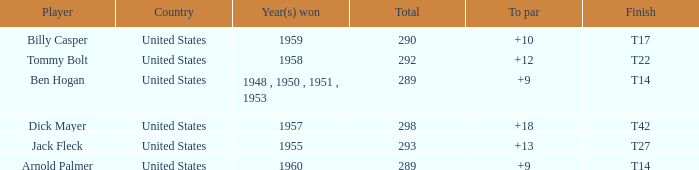What is Player, when Total is 292? Tommy Bolt. 